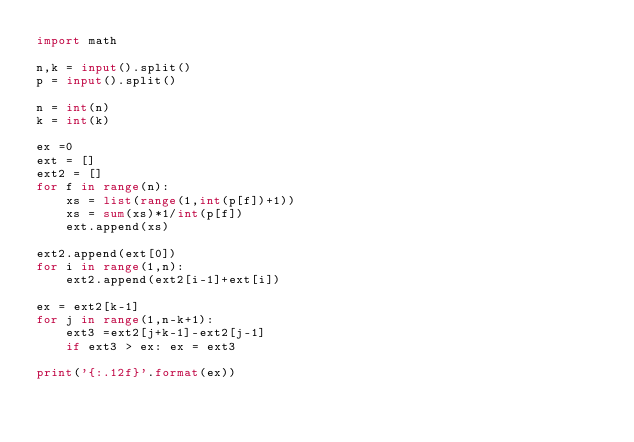Convert code to text. <code><loc_0><loc_0><loc_500><loc_500><_Python_>import math

n,k = input().split()
p = input().split()

n = int(n)
k = int(k)

ex =0
ext = []
ext2 = []
for f in range(n):
    xs = list(range(1,int(p[f])+1))
    xs = sum(xs)*1/int(p[f])
    ext.append(xs)

ext2.append(ext[0])
for i in range(1,n):
    ext2.append(ext2[i-1]+ext[i])

ex = ext2[k-1]
for j in range(1,n-k+1):
    ext3 =ext2[j+k-1]-ext2[j-1]
    if ext3 > ex: ex = ext3

print('{:.12f}'.format(ex))</code> 